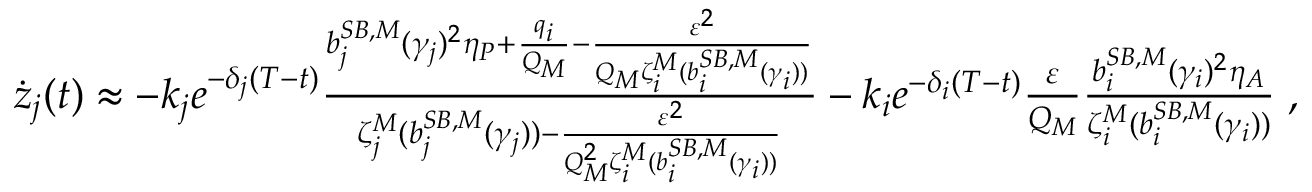Convert formula to latex. <formula><loc_0><loc_0><loc_500><loc_500>\begin{array} { r l } & { \dot { z } _ { j } ( t ) \approx - k _ { j } e ^ { - \delta _ { j } ( T - t ) } \frac { { b } _ { j } ^ { S B , M } ( \gamma _ { j } ) ^ { 2 } \eta _ { P } + \frac { q _ { i } } { Q _ { M } } - \frac { \varepsilon ^ { 2 } } { Q _ { M } \zeta _ { i } ^ { M } ( { b } _ { i } ^ { S B , M } ( \gamma _ { i } ) ) } } { \zeta _ { j } ^ { M } ( { b } _ { j } ^ { S B , M } ( \gamma _ { j } ) ) - \frac { \varepsilon ^ { 2 } } { Q _ { M } ^ { 2 } \zeta _ { i } ^ { M } ( { b } _ { i } ^ { S B , M } ( \gamma _ { i } ) ) } } - k _ { i } e ^ { - \delta _ { i } ( T - t ) } \frac { \varepsilon } { Q _ { M } } \frac { { b } _ { i } ^ { S B , M } ( \gamma _ { i } ) ^ { 2 } \eta _ { A } } { \zeta _ { i } ^ { M } ( { b } _ { i } ^ { S B , M } ( \gamma _ { i } ) ) } \, , } \end{array}</formula> 